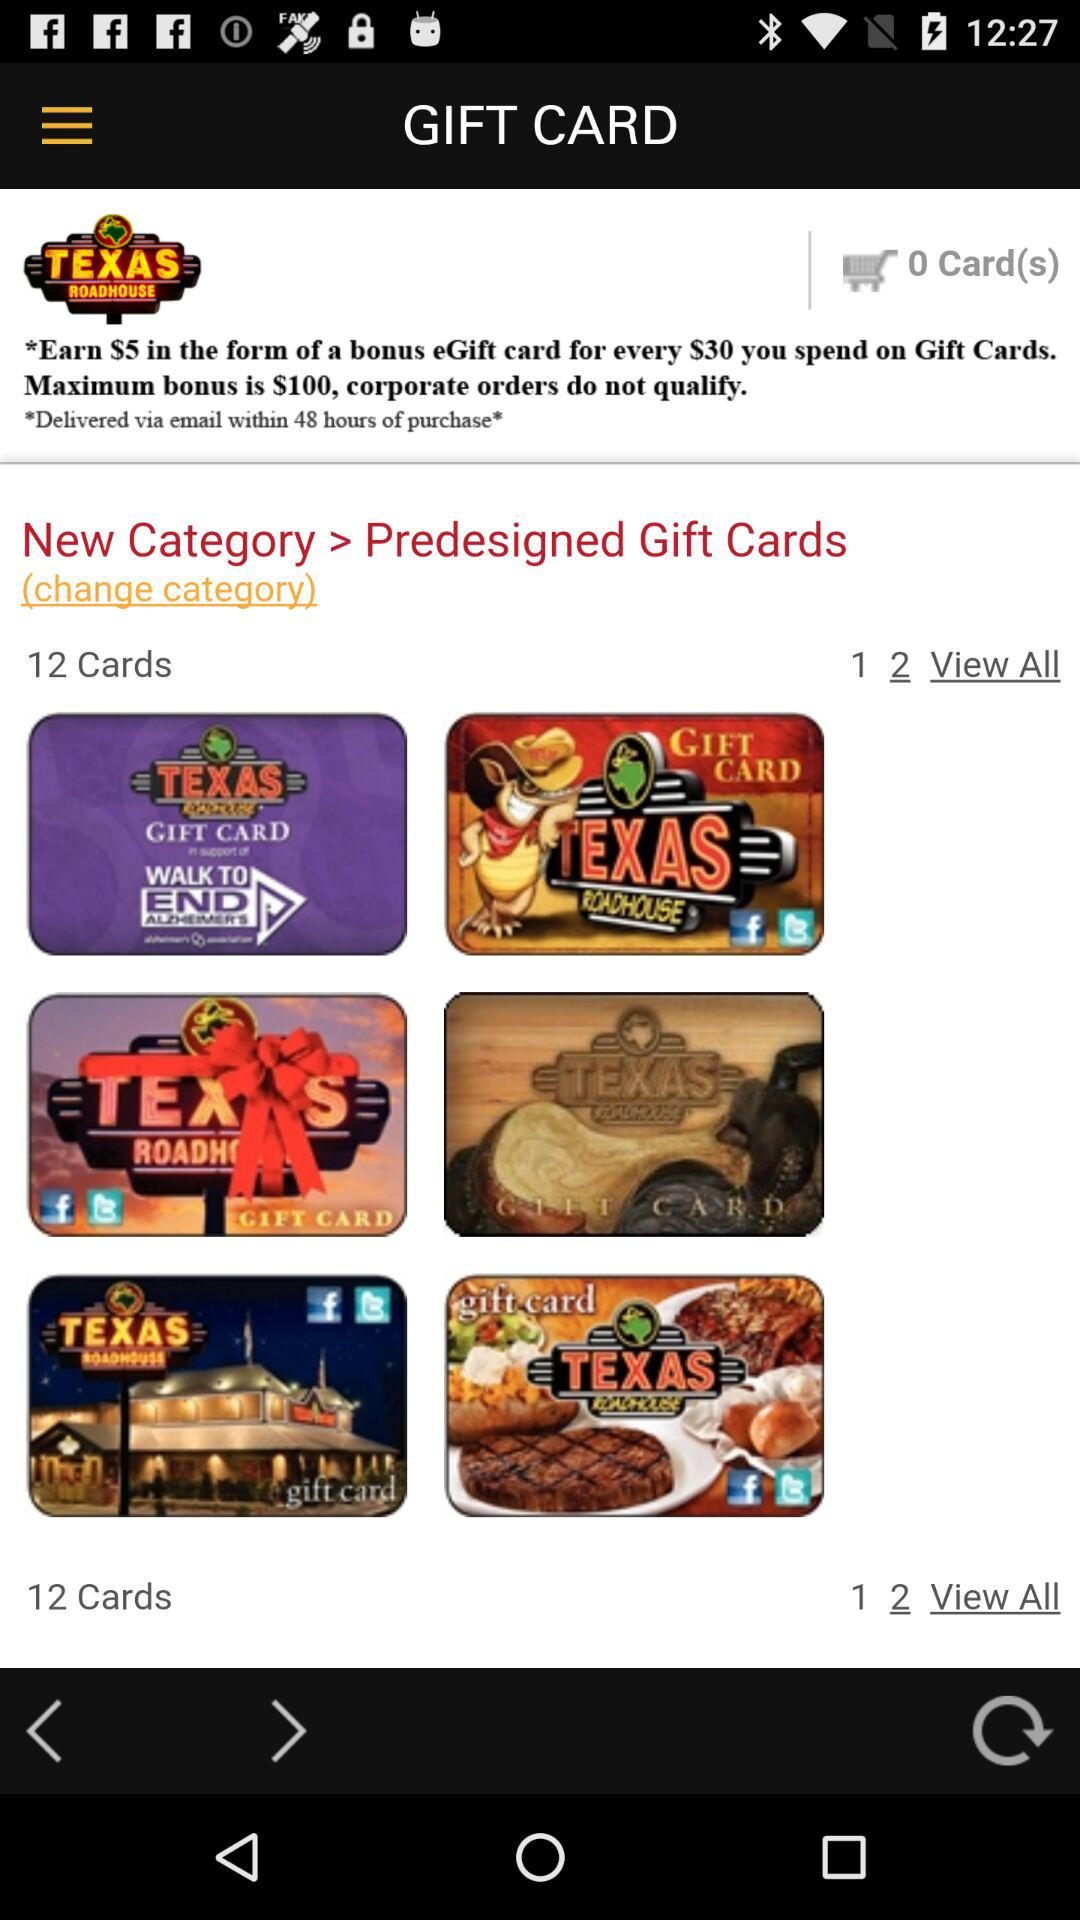What is the maximum bonus? The maximum bonus is $100. 